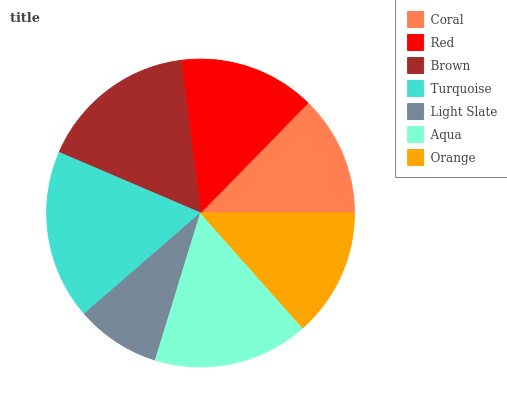Is Light Slate the minimum?
Answer yes or no. Yes. Is Turquoise the maximum?
Answer yes or no. Yes. Is Red the minimum?
Answer yes or no. No. Is Red the maximum?
Answer yes or no. No. Is Red greater than Coral?
Answer yes or no. Yes. Is Coral less than Red?
Answer yes or no. Yes. Is Coral greater than Red?
Answer yes or no. No. Is Red less than Coral?
Answer yes or no. No. Is Red the high median?
Answer yes or no. Yes. Is Red the low median?
Answer yes or no. Yes. Is Turquoise the high median?
Answer yes or no. No. Is Turquoise the low median?
Answer yes or no. No. 